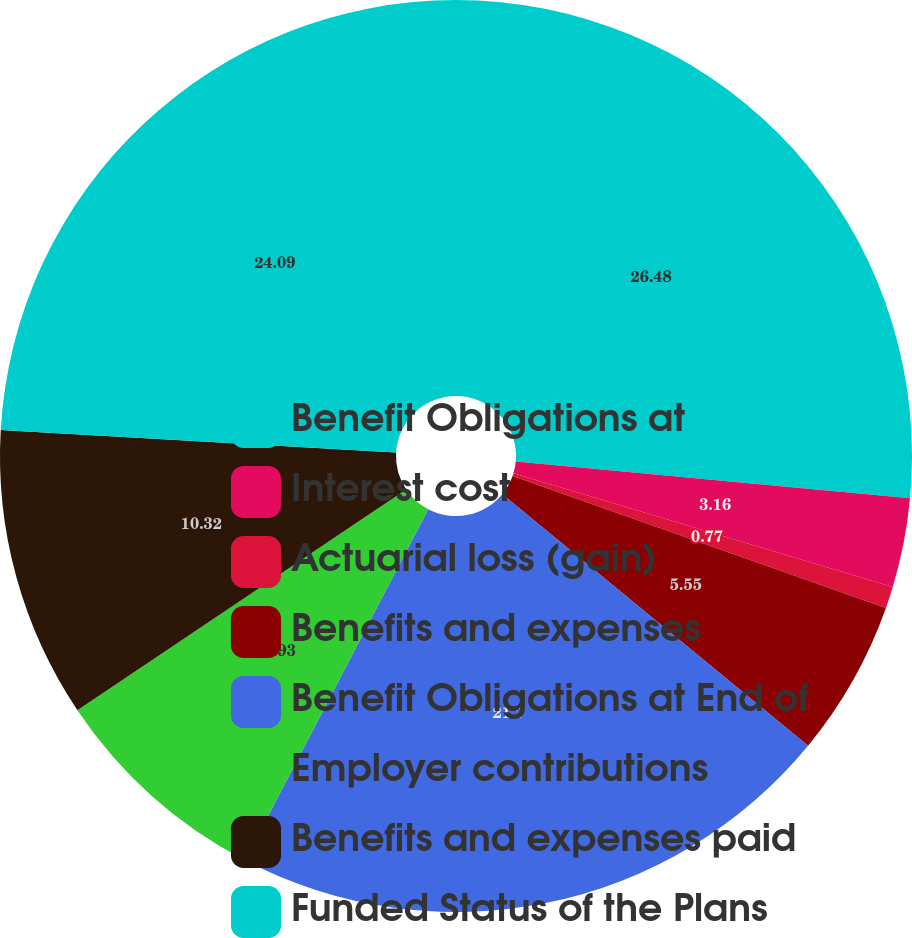Convert chart. <chart><loc_0><loc_0><loc_500><loc_500><pie_chart><fcel>Benefit Obligations at<fcel>Interest cost<fcel>Actuarial loss (gain)<fcel>Benefits and expenses<fcel>Benefit Obligations at End of<fcel>Employer contributions<fcel>Benefits and expenses paid<fcel>Funded Status of the Plans<nl><fcel>26.48%<fcel>3.16%<fcel>0.77%<fcel>5.55%<fcel>21.7%<fcel>7.93%<fcel>10.32%<fcel>24.09%<nl></chart> 